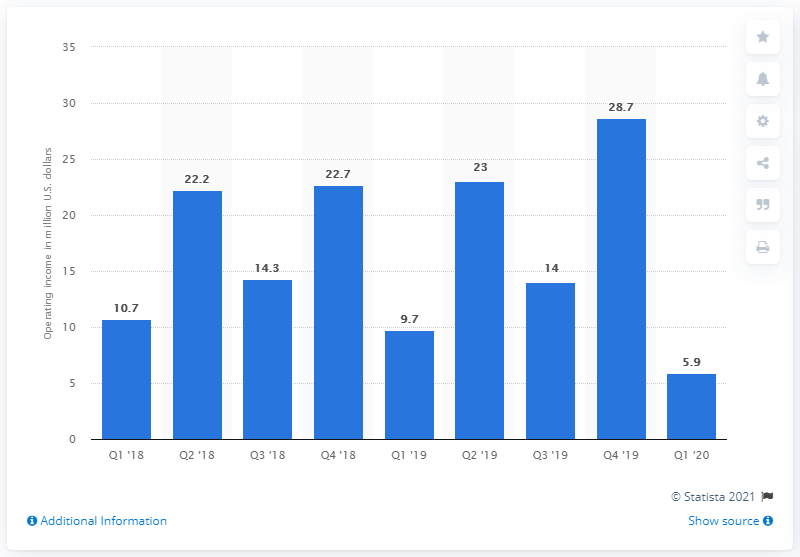Can you describe the trend in Rakuten Rewards' operating income over the reported quarters? The bar graph shows a fluctuating trend in Rakuten Rewards' operating income over the reported quarters, starting at 10.7 million US dollars in Q1 '18 and peaking at 28.7 million in Q4 '19, before dropping to 5.9 million in Q1 '20. 